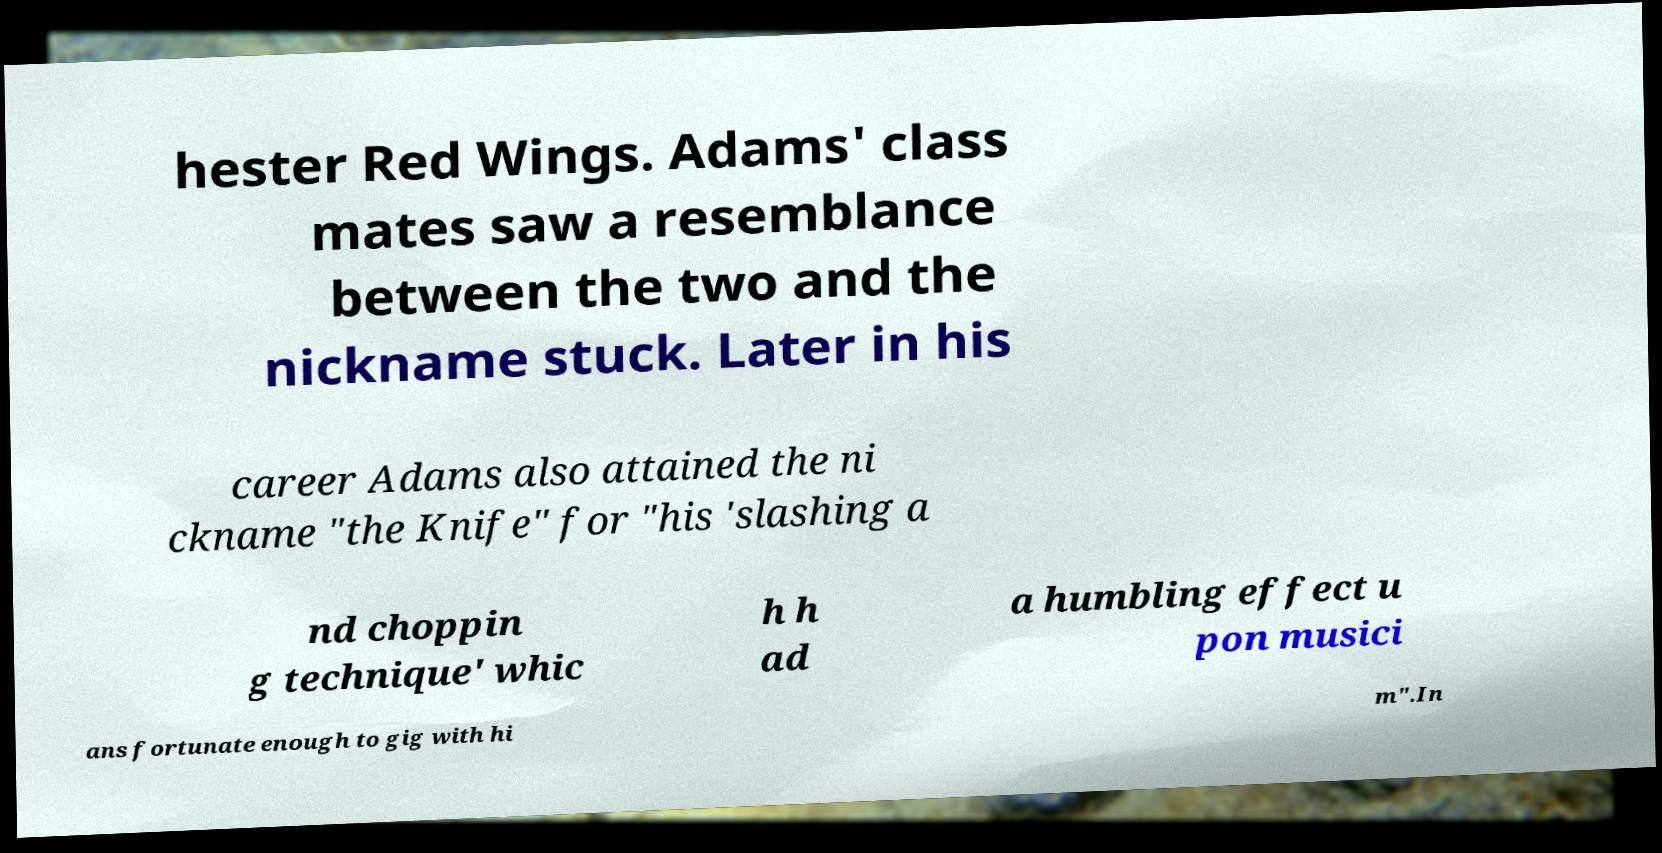Can you accurately transcribe the text from the provided image for me? hester Red Wings. Adams' class mates saw a resemblance between the two and the nickname stuck. Later in his career Adams also attained the ni ckname "the Knife" for "his 'slashing a nd choppin g technique' whic h h ad a humbling effect u pon musici ans fortunate enough to gig with hi m".In 